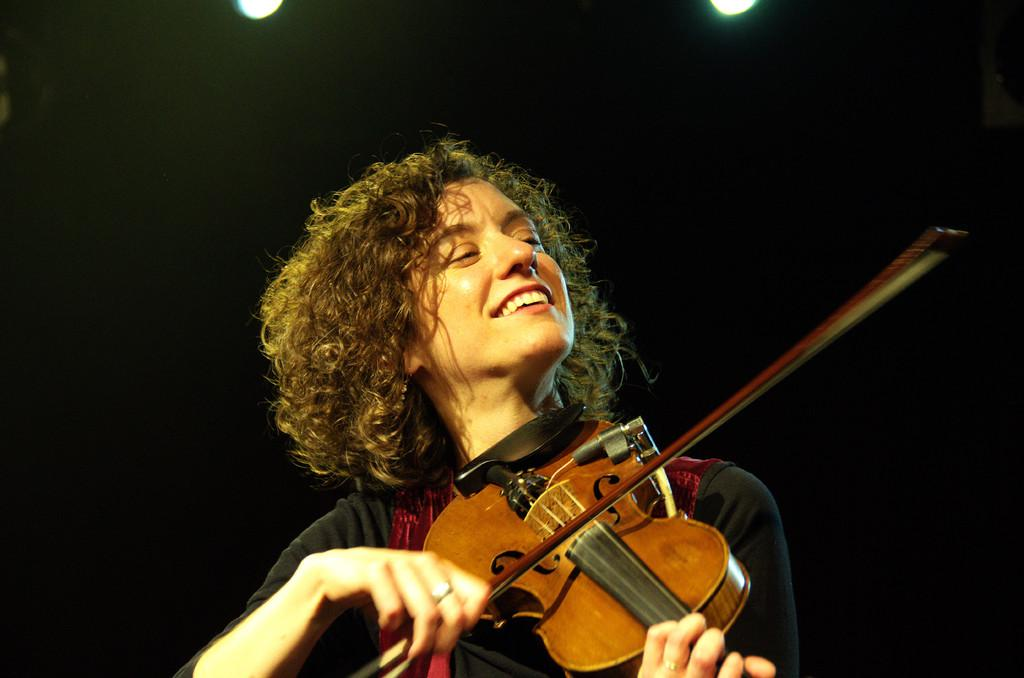Who is the main subject in the image? There is a lady in the image. Can you describe the lady's appearance? The lady has short hair and is wearing a black and red dress. What is the lady holding in the image? The lady is holding a guitar. What is the lady doing with the guitar? The lady is playing the guitar. Where is the man using the rake in the image? There is no man or rake present in the image; it features a lady playing a guitar. 